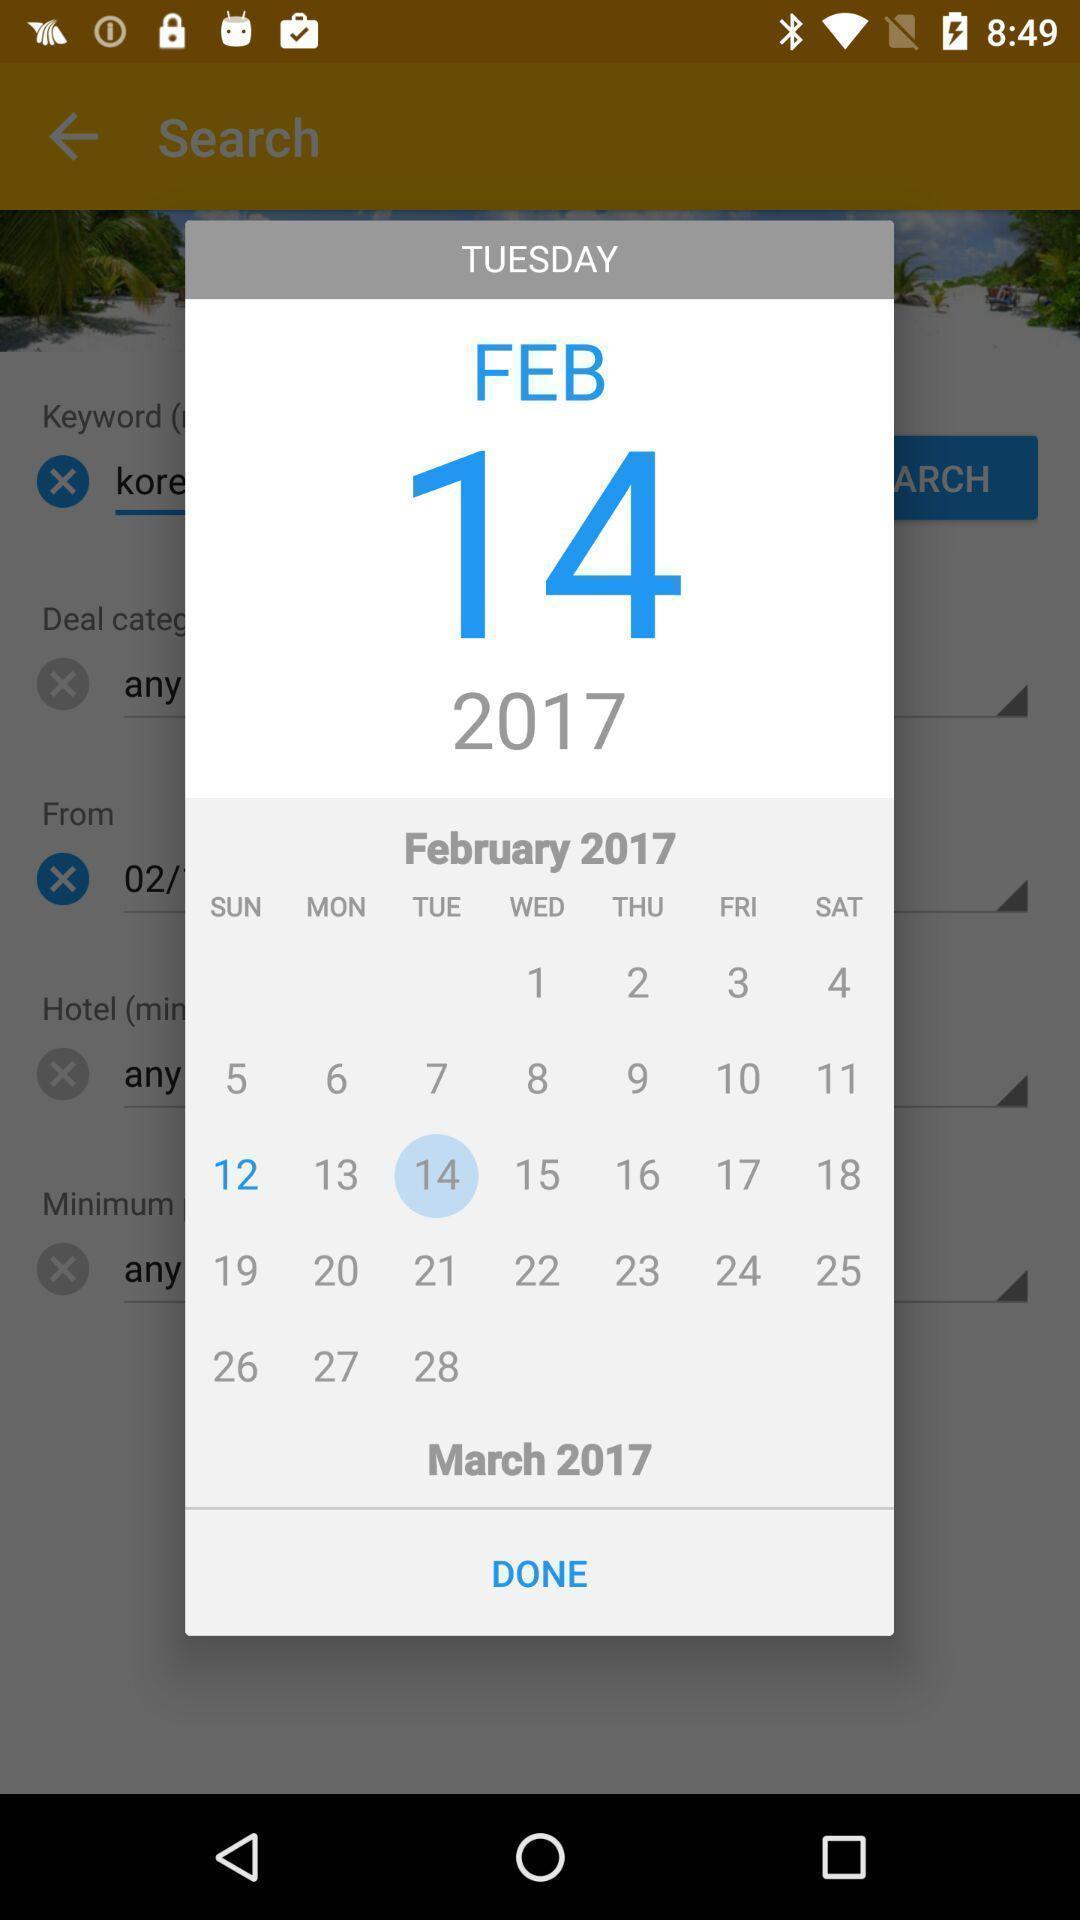Describe the visual elements of this screenshot. Pop-up showing calendar of a month. 